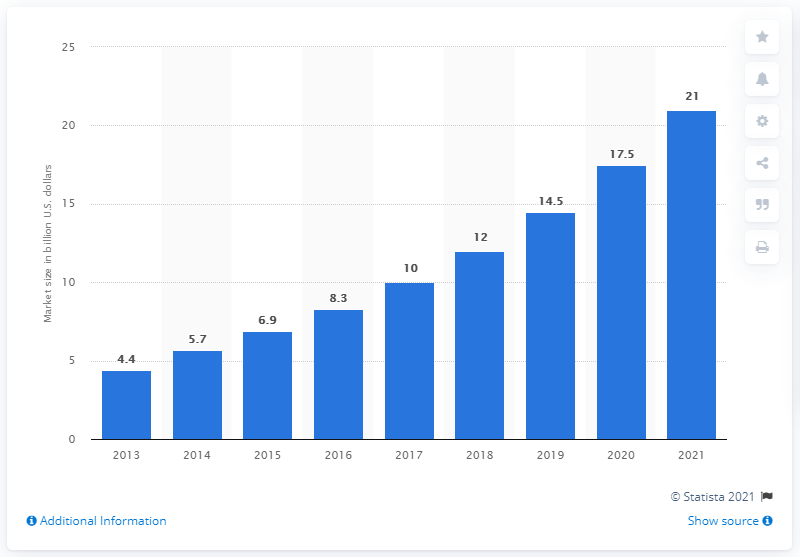Point out several critical features in this image. The global 3D printing market is projected to grow significantly in 2021. 